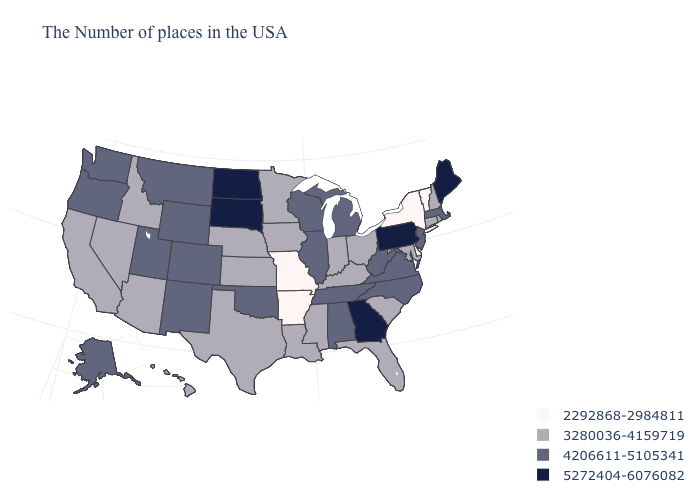Does Maryland have the lowest value in the USA?
Be succinct. No. Name the states that have a value in the range 2292868-2984811?
Write a very short answer. Vermont, New York, Delaware, Missouri, Arkansas. Among the states that border Florida , does Georgia have the lowest value?
Be succinct. No. What is the value of Vermont?
Answer briefly. 2292868-2984811. What is the value of Iowa?
Keep it brief. 3280036-4159719. Among the states that border North Carolina , does South Carolina have the highest value?
Give a very brief answer. No. Does Georgia have the highest value in the USA?
Quick response, please. Yes. Name the states that have a value in the range 3280036-4159719?
Concise answer only. Rhode Island, New Hampshire, Connecticut, Maryland, South Carolina, Ohio, Florida, Kentucky, Indiana, Mississippi, Louisiana, Minnesota, Iowa, Kansas, Nebraska, Texas, Arizona, Idaho, Nevada, California, Hawaii. What is the lowest value in the South?
Answer briefly. 2292868-2984811. What is the value of Virginia?
Short answer required. 4206611-5105341. Name the states that have a value in the range 2292868-2984811?
Give a very brief answer. Vermont, New York, Delaware, Missouri, Arkansas. What is the value of Georgia?
Concise answer only. 5272404-6076082. What is the value of Texas?
Be succinct. 3280036-4159719. What is the highest value in states that border Indiana?
Quick response, please. 4206611-5105341. 